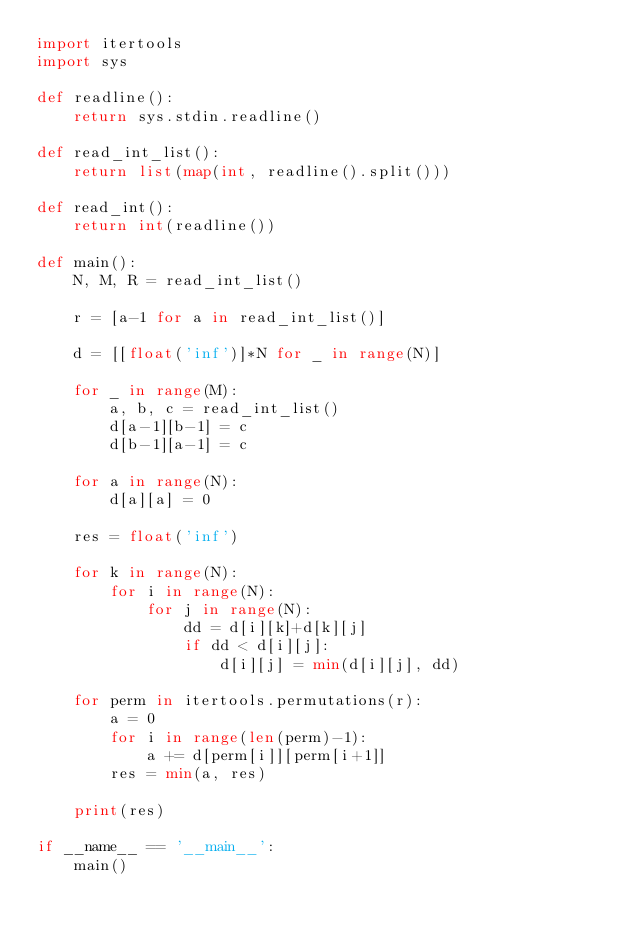<code> <loc_0><loc_0><loc_500><loc_500><_Python_>import itertools
import sys

def readline():
    return sys.stdin.readline()

def read_int_list():
    return list(map(int, readline().split()))

def read_int():
    return int(readline())

def main():
    N, M, R = read_int_list()

    r = [a-1 for a in read_int_list()]

    d = [[float('inf')]*N for _ in range(N)]

    for _ in range(M):
        a, b, c = read_int_list()
        d[a-1][b-1] = c
        d[b-1][a-1] = c

    for a in range(N):
        d[a][a] = 0

    res = float('inf')

    for k in range(N):
        for i in range(N):
            for j in range(N):
                dd = d[i][k]+d[k][j]
                if dd < d[i][j]:
                    d[i][j] = min(d[i][j], dd)

    for perm in itertools.permutations(r):
        a = 0
        for i in range(len(perm)-1):
            a += d[perm[i]][perm[i+1]]
        res = min(a, res)

    print(res)

if __name__ == '__main__':
    main()
</code> 